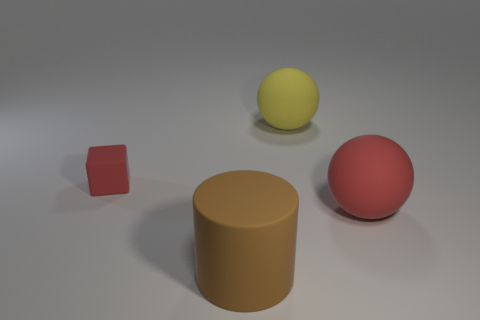What time of day does the lighting in this image suggest? The lighting in the image appears soft and diffused, without any strong shadows that might indicate a particular time of day. It's likely intended to mimic an overcast sky or indoor lighting rather than direct sunlight. 